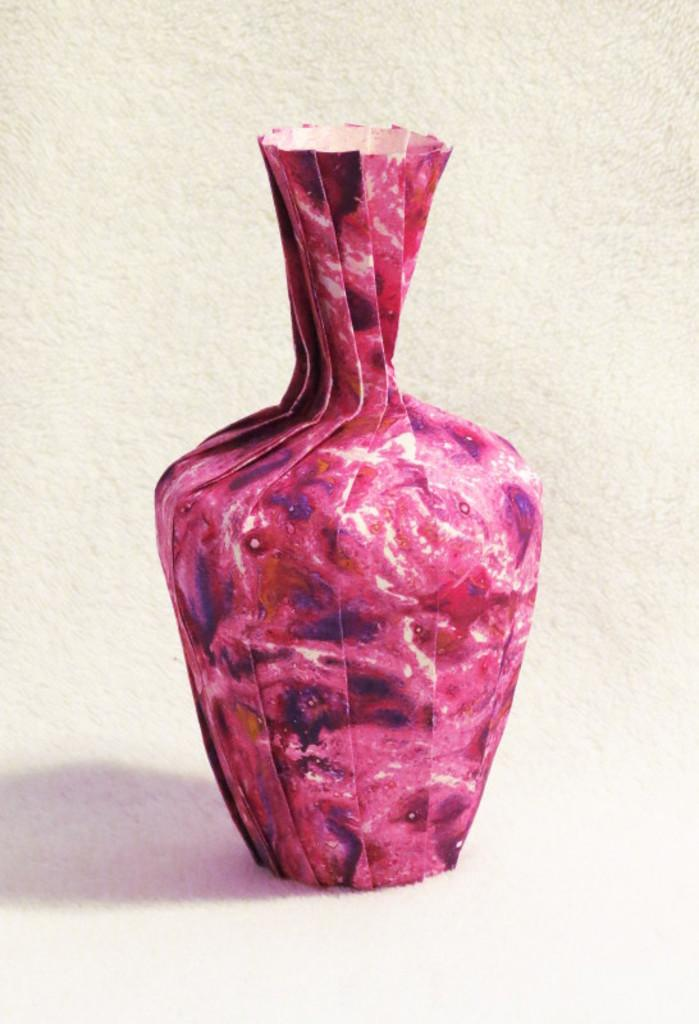What is the main object in the image? There is a vase in the image. What type of floor covering is present in the image? There is a carpet in the image. Can you see an owl perched on the vase in the image? There is no owl present in the image. Is there a snake slithering across the carpet in the image? There is no snake present in the image. 